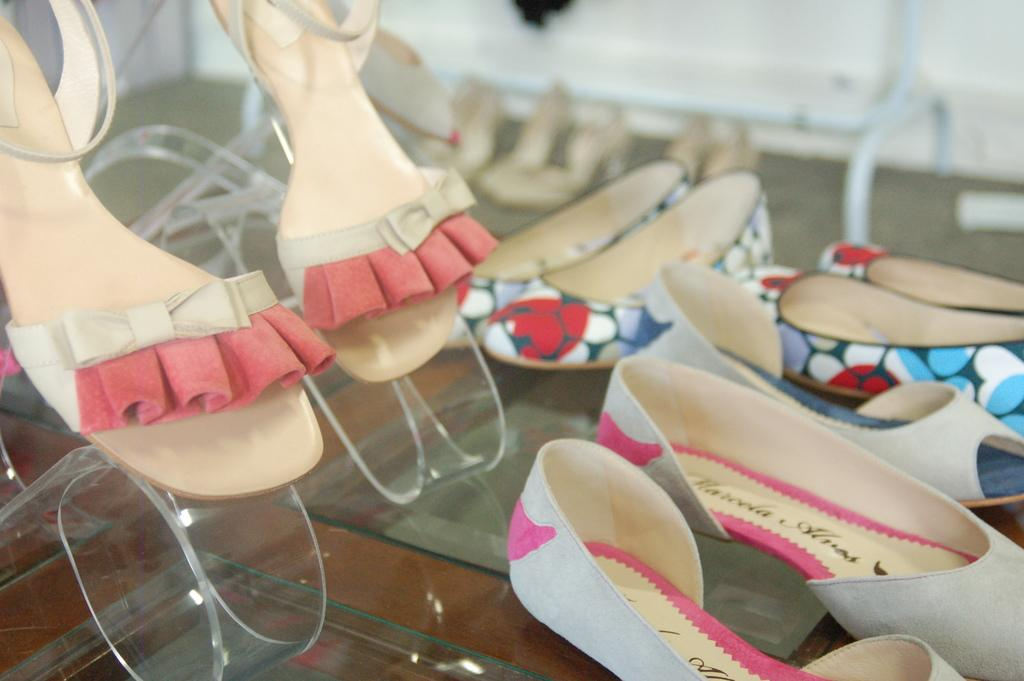What type of footwear can be seen in the image? There are shoes and sandals in the image. How are the shoes and sandals arranged in the image? The shoes and sandals are kept on a shoe stand. What type of rake is used to clean the shoes in the image? There is no rake present in the image, and the shoes are not being cleaned. 